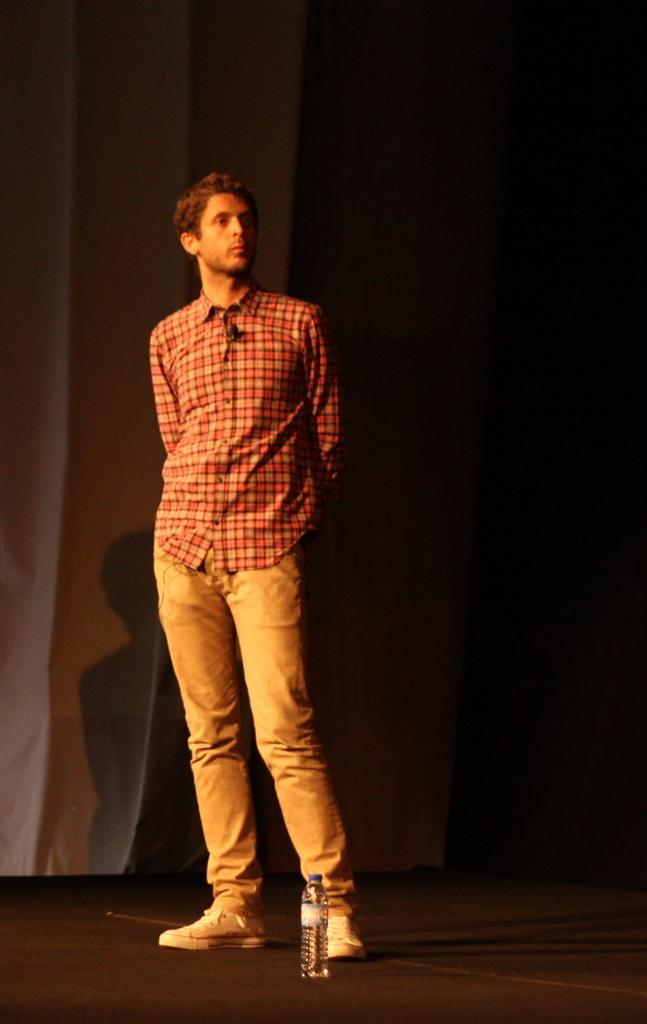What is the main subject of the image? There is a person in the image. What is the person wearing? The person is wearing an orange shirt. What is the person holding in the image? The person is holding a bottle. What can be seen on the left side of the image? There is a curtain on the left side of the image. How would you describe the lighting in the image? The image appears to be slightly dark. Are there any pets visible in the image? There are no pets present in the image. What type of brain can be seen in the image? There is no brain visible in the image. 